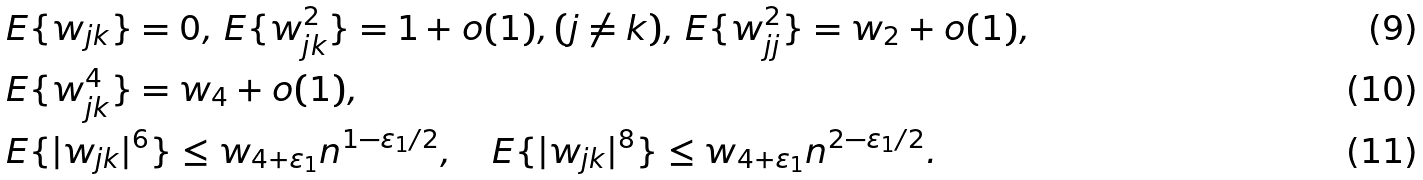Convert formula to latex. <formula><loc_0><loc_0><loc_500><loc_500>& E \{ w _ { j k } \} = 0 , \, E \{ w _ { j k } ^ { 2 } \} = 1 + o ( 1 ) , ( j \not = k ) , \, E \{ w _ { j j } ^ { 2 } \} = w _ { 2 } + o ( 1 ) , \\ & E \{ w _ { j k } ^ { 4 } \} = w _ { 4 } + o ( 1 ) , \\ & E \{ | w _ { j k } | ^ { 6 } \} \leq w _ { 4 + \varepsilon _ { 1 } } n ^ { 1 - \varepsilon _ { 1 } / 2 } , \quad E \{ | w _ { j k } | ^ { 8 } \} \leq w _ { 4 + \varepsilon _ { 1 } } n ^ { 2 - \varepsilon _ { 1 } / 2 } .</formula> 